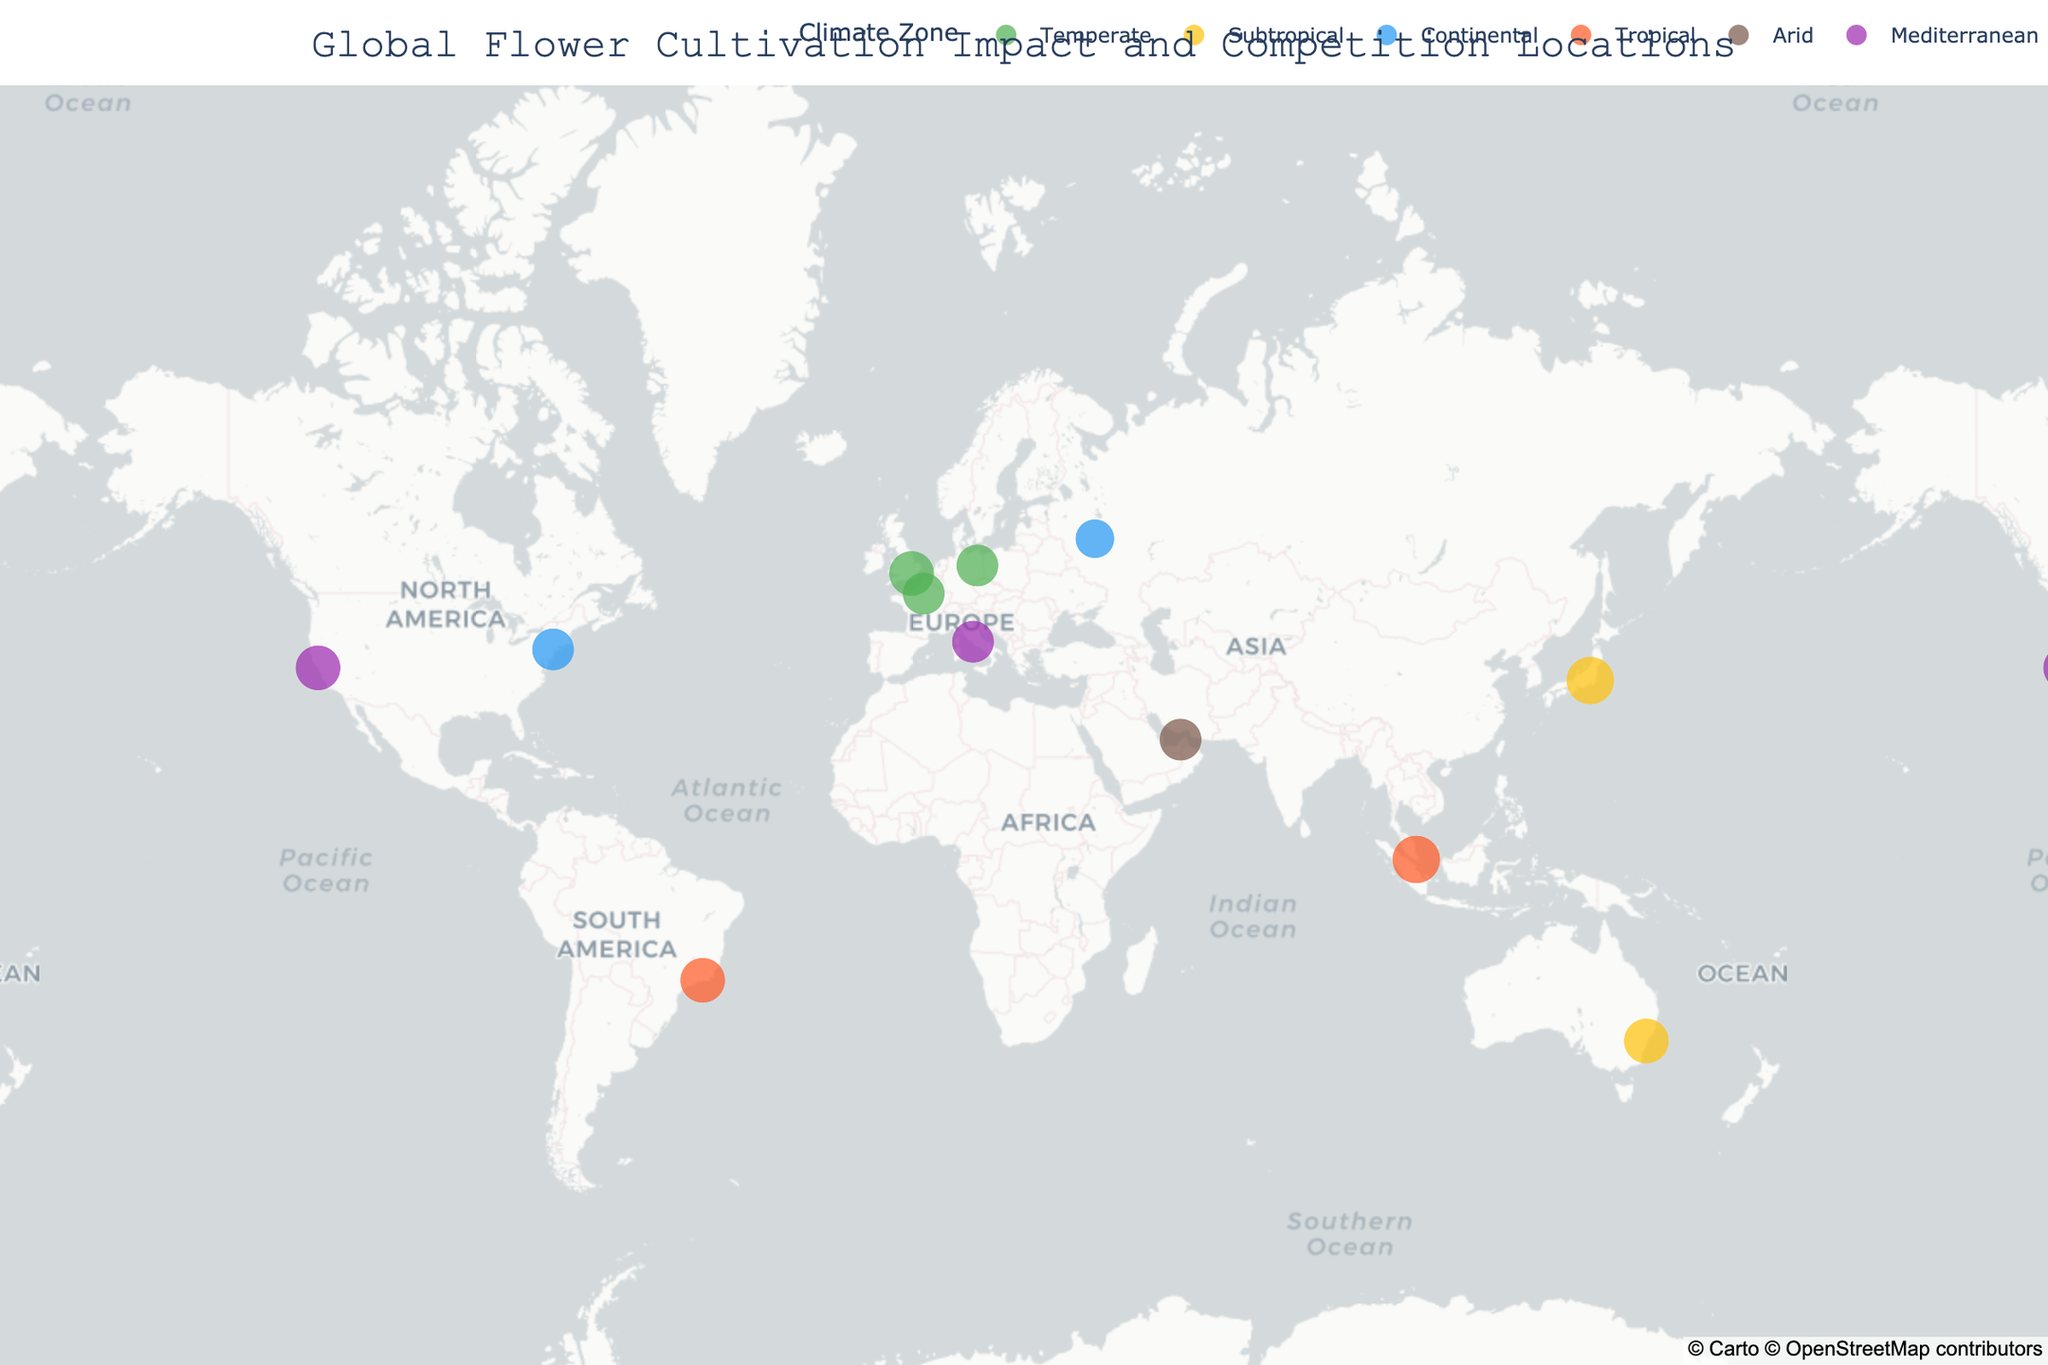How many climate zones are represented on the figure? Count the distinct colors representing various climate zones in the map legend.
Answer: 6 Which flower type has the highest impact score in a tropical climate zone? Locate the points with 'Tropical' climates on the map or legend, then identify the flower type with the highest impact score from those points. Both Singapore (Bird of Paradise) and Rio de Janeiro (Anthurium) in tropical climates have an impact score of 9.
Answer: Bird of Paradise, Anthurium What is the climate zone of Rome, and what is the associated flower type? Find Rome on the map or hover over it to see the climate zone and flower type. The climate zone of Rome is Mediterranean, and the associated flower type is Anemone.
Answer: Mediterranean, Anemone Among Sydney and New York City, which has a higher impact score and by how much? Compare the impact scores of Sydney and New York City. Sydney has an impact score of 8 and New York City has an impact score of 7. The difference is 8 - 7 = 1.
Answer: Sydney by 1 Which competition location has a continental climate and the lowest impact score, and what is the flower type? Identify the points with a 'Continental' climate, then find the one with the lowest impact score. Moscow has a 'Continental' climate and an impact score of 6, associated with Sunflower.
Answer: Moscow, Sunflower What is the combined impact score for all flower types in temperate climate zones? Sum the impact scores for all points in the 'Temperate' climate zone. London (8), Paris (7), Berlin (7). Total: 8 + 7 + 7 = 22.
Answer: 22 Which climate zone appears the most frequently on the map? Count the occurrences of each climate zone and determine which has the highest count. Temperate (London, Paris, Berlin) appears the most frequently with 3 occurrences.
Answer: Temperate Is there any location with an arid climate, and what flower type is cultivated there? Look for the point(s) colored to represent 'Arid' climate; it's Dubai. The flower type cultivated there is Desert Rose.
Answer: Dubai, Desert Rose 